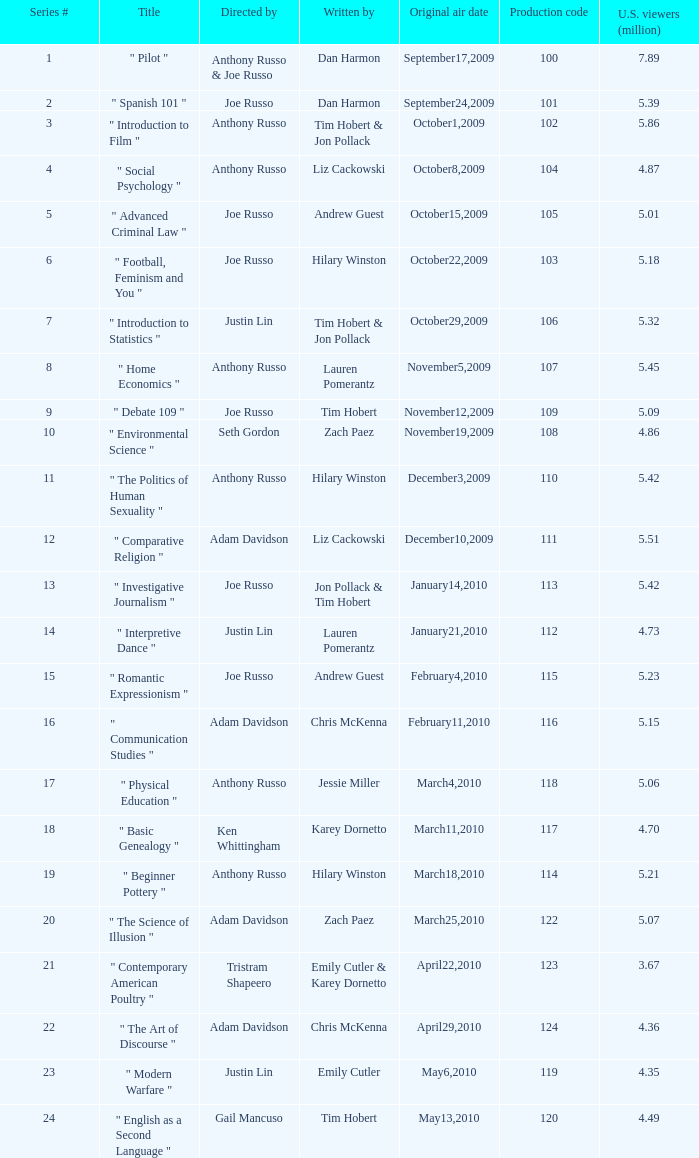What is the designation of the series # 8? " Home Economics ". 